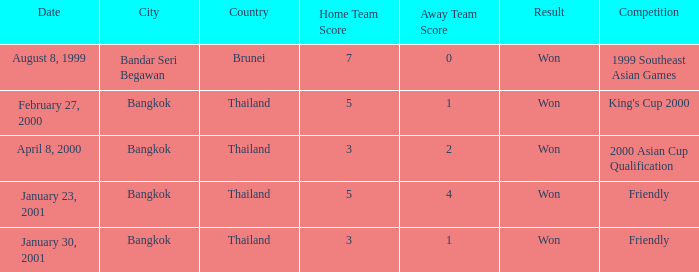When did the game with a final score of 7-0 take place? August 8, 1999. Can you parse all the data within this table? {'header': ['Date', 'City', 'Country', 'Home Team Score', 'Away Team Score', 'Result', 'Competition'], 'rows': [['August 8, 1999', 'Bandar Seri Begawan', 'Brunei', '7', '0', 'Won', '1999 Southeast Asian Games'], ['February 27, 2000', 'Bangkok', 'Thailand', '5', '1', 'Won', "King's Cup 2000"], ['April 8, 2000', 'Bangkok', 'Thailand', '3', '2', 'Won', '2000 Asian Cup Qualification'], ['January 23, 2001', 'Bangkok', 'Thailand', '5', '4', 'Won', 'Friendly'], ['January 30, 2001', 'Bangkok', 'Thailand', '3', '1', 'Won', 'Friendly']]} 